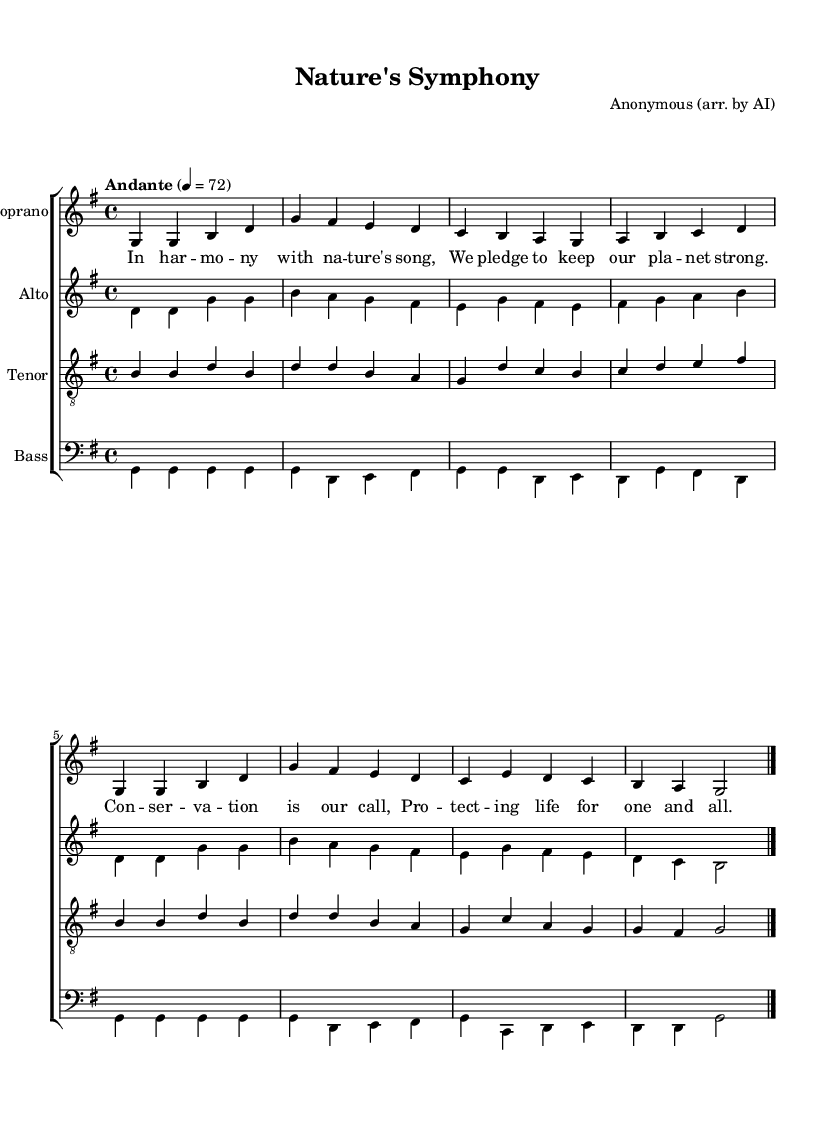What is the key signature of this music? The key signature is G major, which contains one sharp (F#). This can be identified by looking at the key signature at the beginning of the staff lines.
Answer: G major What is the time signature of this piece? The time signature is 4/4, which indicates there are four beats in each measure and the quarter note receives one beat. This is shown at the beginning of the sheet music.
Answer: 4/4 What is the tempo marking of this composition? The tempo marking states "Andante," which means at a moderate speed. This is specified in the tempo indication above the staff.
Answer: Andante How many voices are present in this choral arrangement? There are four voices present: soprano, alto, tenor, and bass. This can be determined by assessing the number of distinct staves labeled for each voice.
Answer: Four Which voice sings the lowest part? The bass voice sings the lowest part. This is evident by looking at the staff labeled for bass, which is positioned lower on the page compared to the other voices.
Answer: Bass What lyrical theme does this piece express? The theme expressed in the lyrics is conservation and ecological harmony, as indicated by the sung lyrics that mention pledging to protect the planet. This is derived from the text lyrics written under the notes.
Answer: Conservation What form of music is represented in this arrangement? This choral arrangement represents a folk song style, as indicated by the lyrical content which reflects themes of nature and community. The style can be inferred from the arrangement's focus on melody and harmony characteristic of folk tradition.
Answer: Folk song 